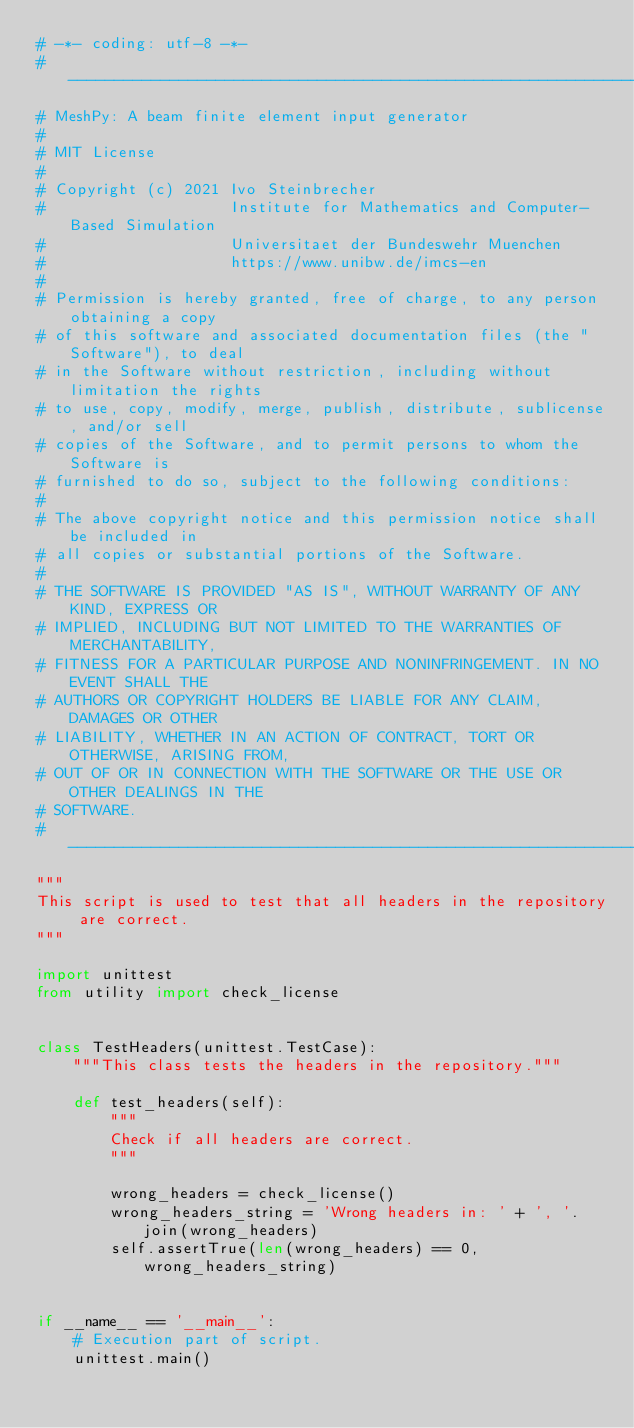Convert code to text. <code><loc_0><loc_0><loc_500><loc_500><_Python_># -*- coding: utf-8 -*-
# -----------------------------------------------------------------------------
# MeshPy: A beam finite element input generator
#
# MIT License
#
# Copyright (c) 2021 Ivo Steinbrecher
#                    Institute for Mathematics and Computer-Based Simulation
#                    Universitaet der Bundeswehr Muenchen
#                    https://www.unibw.de/imcs-en
#
# Permission is hereby granted, free of charge, to any person obtaining a copy
# of this software and associated documentation files (the "Software"), to deal
# in the Software without restriction, including without limitation the rights
# to use, copy, modify, merge, publish, distribute, sublicense, and/or sell
# copies of the Software, and to permit persons to whom the Software is
# furnished to do so, subject to the following conditions:
#
# The above copyright notice and this permission notice shall be included in
# all copies or substantial portions of the Software.
#
# THE SOFTWARE IS PROVIDED "AS IS", WITHOUT WARRANTY OF ANY KIND, EXPRESS OR
# IMPLIED, INCLUDING BUT NOT LIMITED TO THE WARRANTIES OF MERCHANTABILITY,
# FITNESS FOR A PARTICULAR PURPOSE AND NONINFRINGEMENT. IN NO EVENT SHALL THE
# AUTHORS OR COPYRIGHT HOLDERS BE LIABLE FOR ANY CLAIM, DAMAGES OR OTHER
# LIABILITY, WHETHER IN AN ACTION OF CONTRACT, TORT OR OTHERWISE, ARISING FROM,
# OUT OF OR IN CONNECTION WITH THE SOFTWARE OR THE USE OR OTHER DEALINGS IN THE
# SOFTWARE.
# -----------------------------------------------------------------------------
"""
This script is used to test that all headers in the repository are correct.
"""

import unittest
from utility import check_license


class TestHeaders(unittest.TestCase):
    """This class tests the headers in the repository."""

    def test_headers(self):
        """
        Check if all headers are correct.
        """

        wrong_headers = check_license()
        wrong_headers_string = 'Wrong headers in: ' + ', '.join(wrong_headers)
        self.assertTrue(len(wrong_headers) == 0, wrong_headers_string)


if __name__ == '__main__':
    # Execution part of script.
    unittest.main()
</code> 